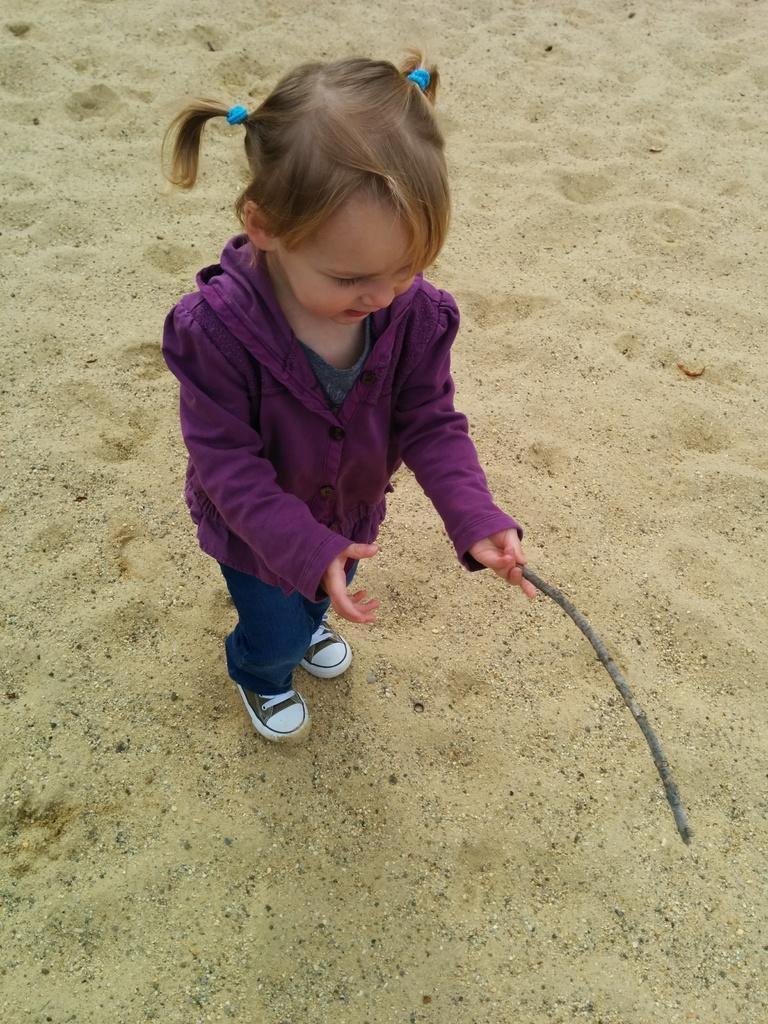Can you describe this image briefly? In the picture we can see a kid wearing purple color sweater, blue color pant, black color shoe, holding a stick in her hands and we can see sand. 